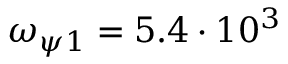Convert formula to latex. <formula><loc_0><loc_0><loc_500><loc_500>\omega _ { \psi 1 } = 5 . 4 \cdot 1 0 ^ { 3 }</formula> 